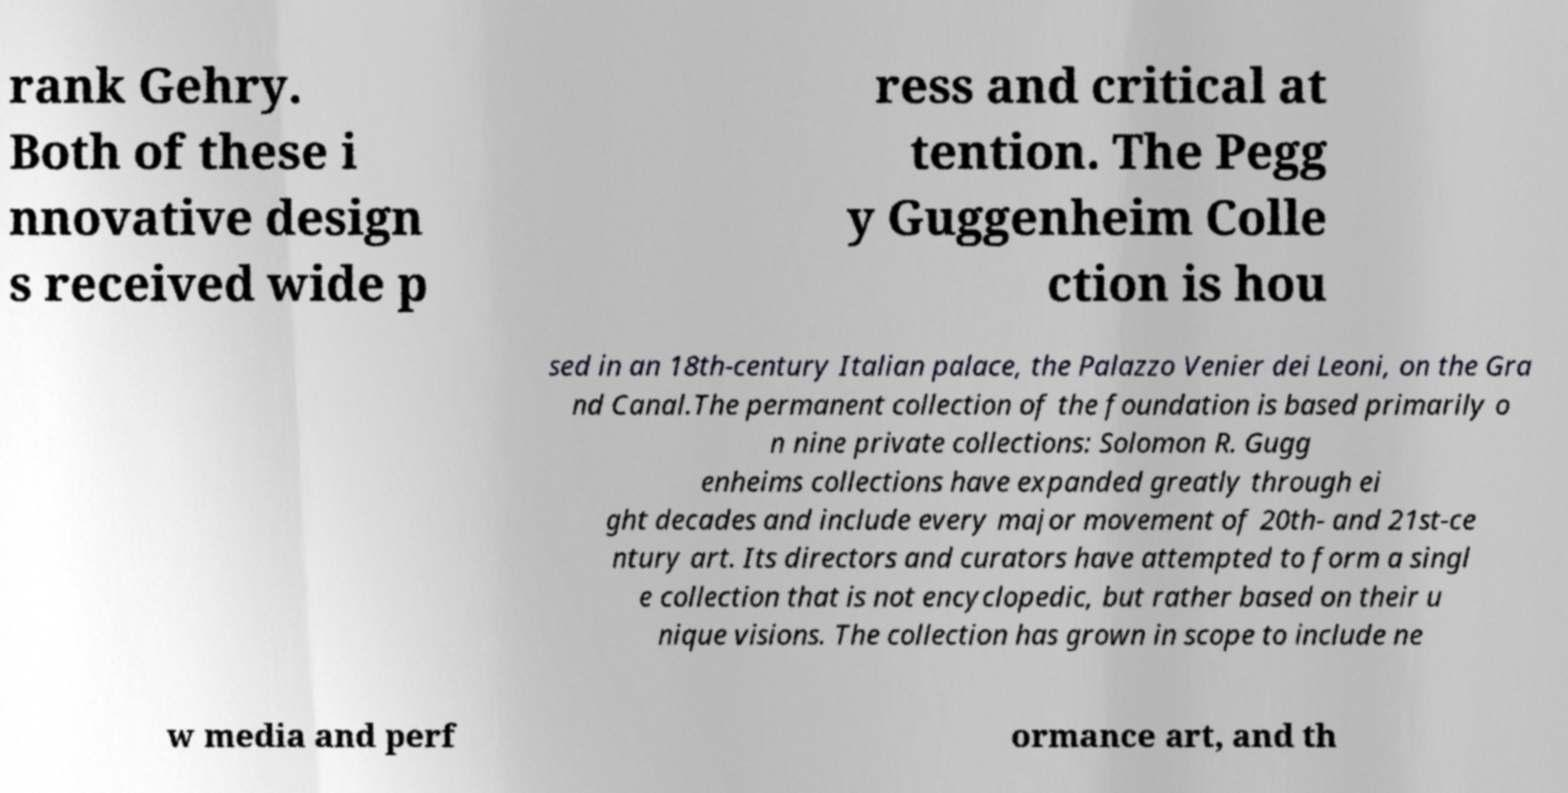There's text embedded in this image that I need extracted. Can you transcribe it verbatim? rank Gehry. Both of these i nnovative design s received wide p ress and critical at tention. The Pegg y Guggenheim Colle ction is hou sed in an 18th-century Italian palace, the Palazzo Venier dei Leoni, on the Gra nd Canal.The permanent collection of the foundation is based primarily o n nine private collections: Solomon R. Gugg enheims collections have expanded greatly through ei ght decades and include every major movement of 20th- and 21st-ce ntury art. Its directors and curators have attempted to form a singl e collection that is not encyclopedic, but rather based on their u nique visions. The collection has grown in scope to include ne w media and perf ormance art, and th 